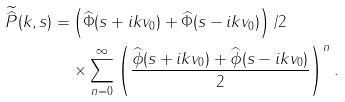Convert formula to latex. <formula><loc_0><loc_0><loc_500><loc_500>\widetilde { \widehat { P } } ( k , s ) = & \left ( \widehat { \Phi } ( s + i k v _ { 0 } ) + \widehat { \Phi } ( s - i k v _ { 0 } ) \right ) / 2 \\ & \times \sum _ { n = 0 } ^ { \infty } \left ( \frac { \widehat { \phi } ( s + i k v _ { 0 } ) + \widehat { \phi } ( s - i k v _ { 0 } ) } { 2 } \right ) ^ { n } .</formula> 